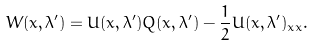Convert formula to latex. <formula><loc_0><loc_0><loc_500><loc_500>W ( x , \lambda ^ { \prime } ) = U ( x , \lambda ^ { \prime } ) Q ( x , \lambda ^ { \prime } ) - \frac { 1 } { 2 } U ( x , \lambda ^ { \prime } ) _ { x x } .</formula> 